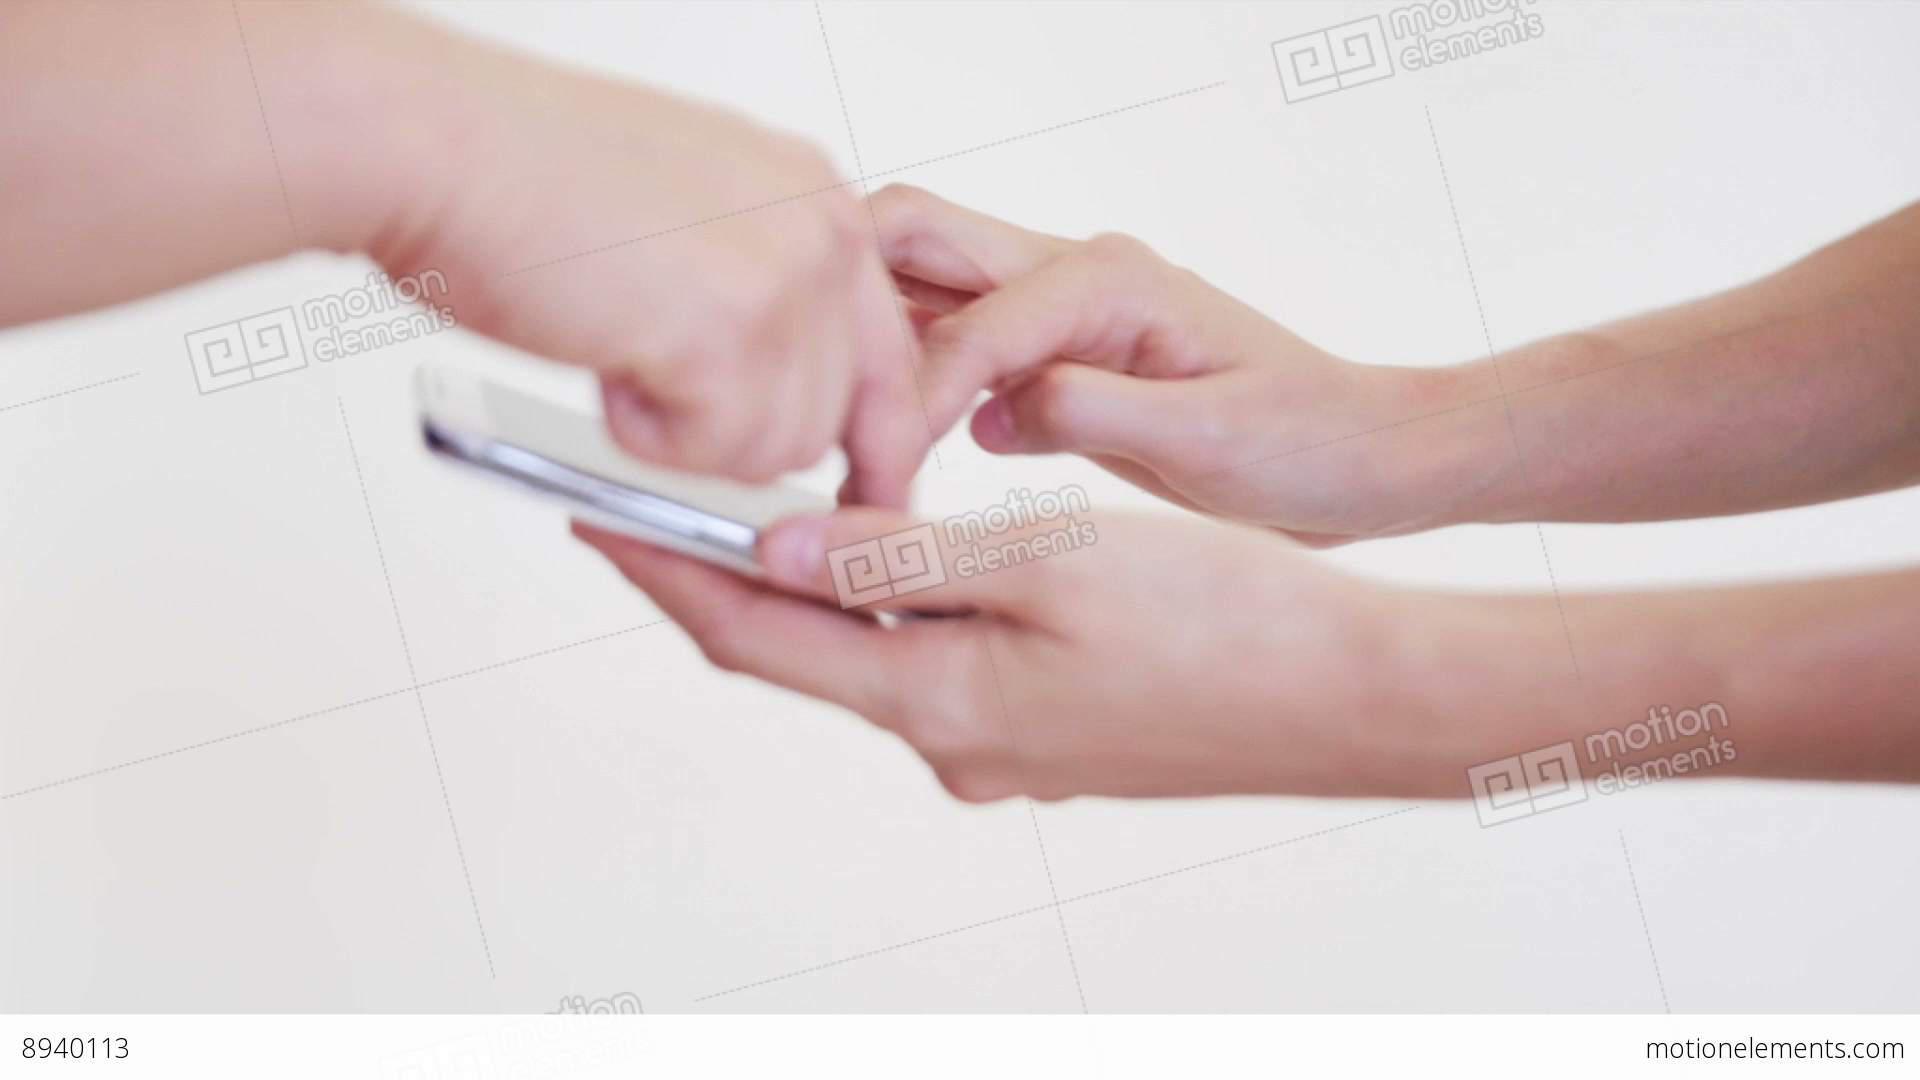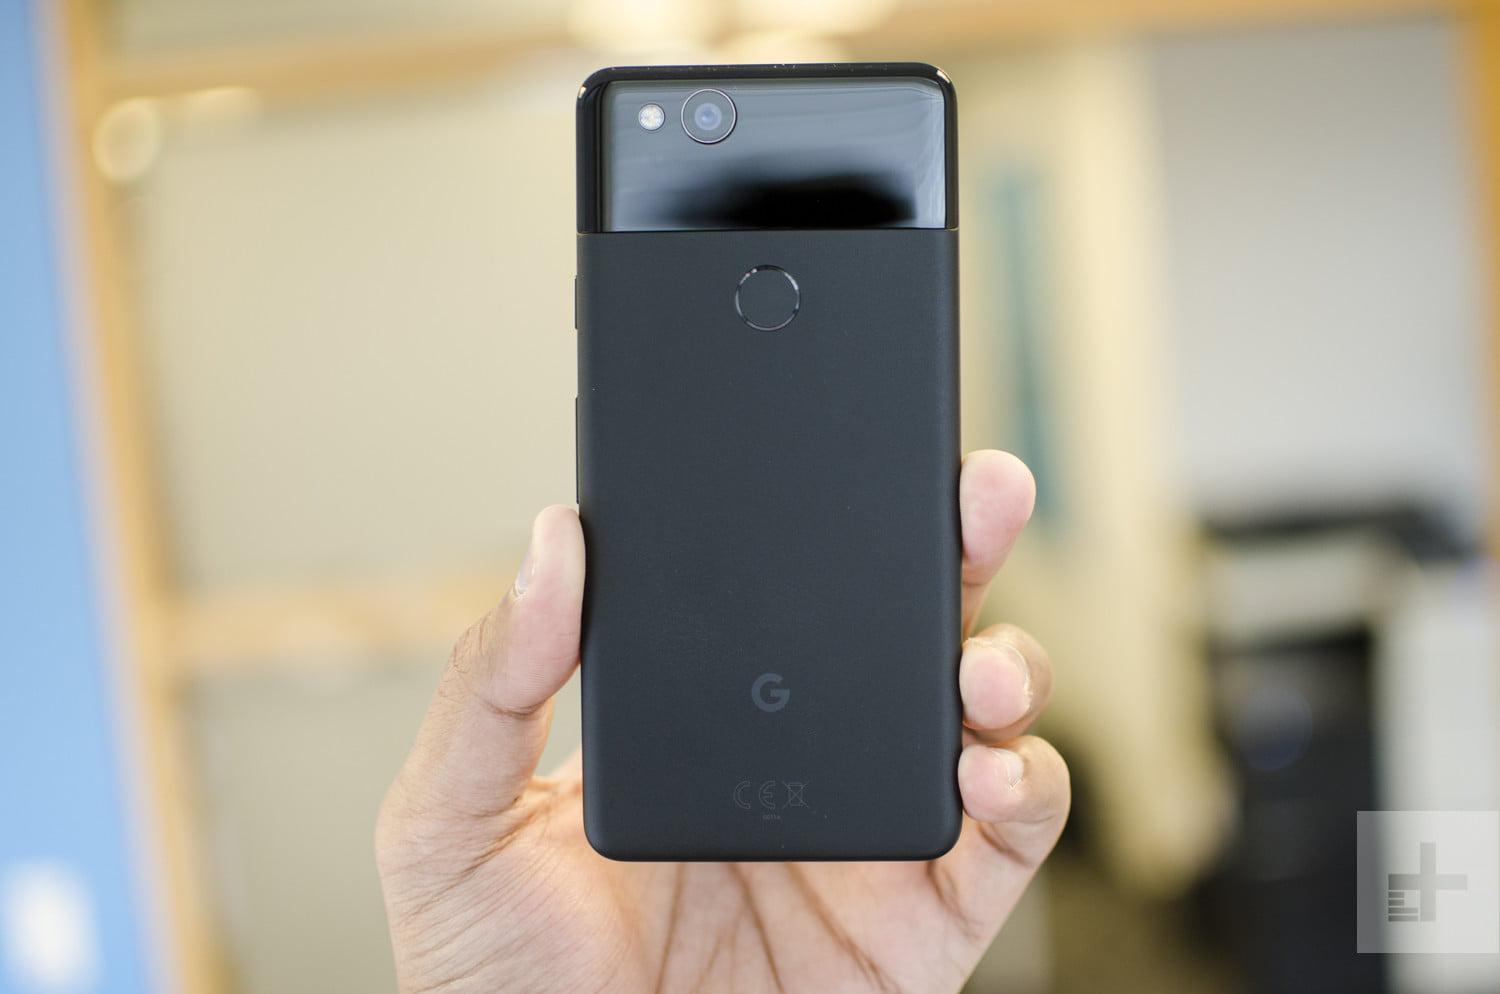The first image is the image on the left, the second image is the image on the right. For the images displayed, is the sentence "Exactly one phones is in contact with a single hand." factually correct? Answer yes or no. No. The first image is the image on the left, the second image is the image on the right. Given the left and right images, does the statement "A single hand is holding a phone upright and head-on in one image, and the other image includes hands reaching in from opposite sides." hold true? Answer yes or no. Yes. 